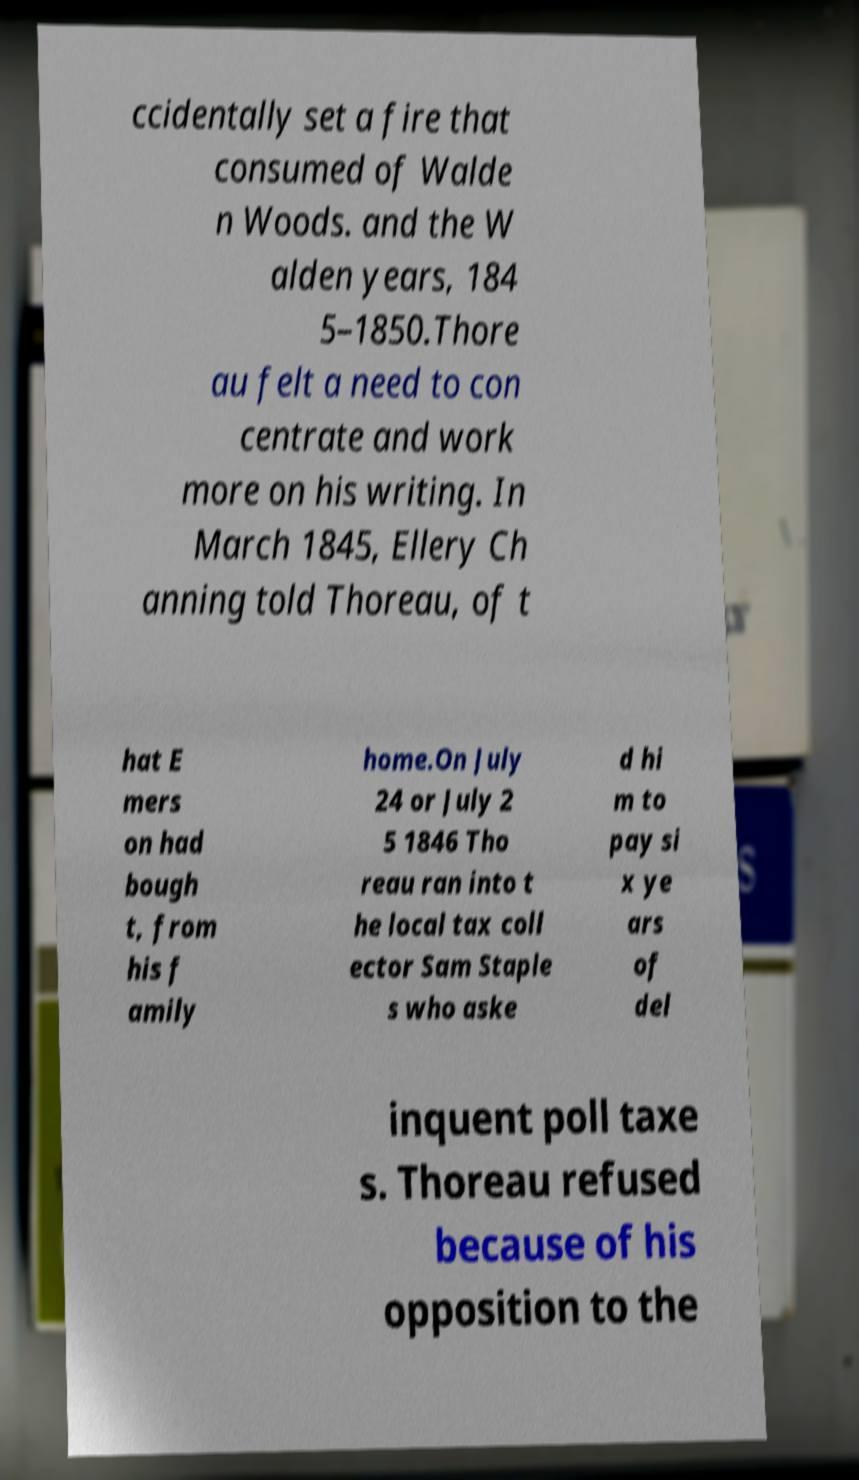Please identify and transcribe the text found in this image. ccidentally set a fire that consumed of Walde n Woods. and the W alden years, 184 5–1850.Thore au felt a need to con centrate and work more on his writing. In March 1845, Ellery Ch anning told Thoreau, of t hat E mers on had bough t, from his f amily home.On July 24 or July 2 5 1846 Tho reau ran into t he local tax coll ector Sam Staple s who aske d hi m to pay si x ye ars of del inquent poll taxe s. Thoreau refused because of his opposition to the 